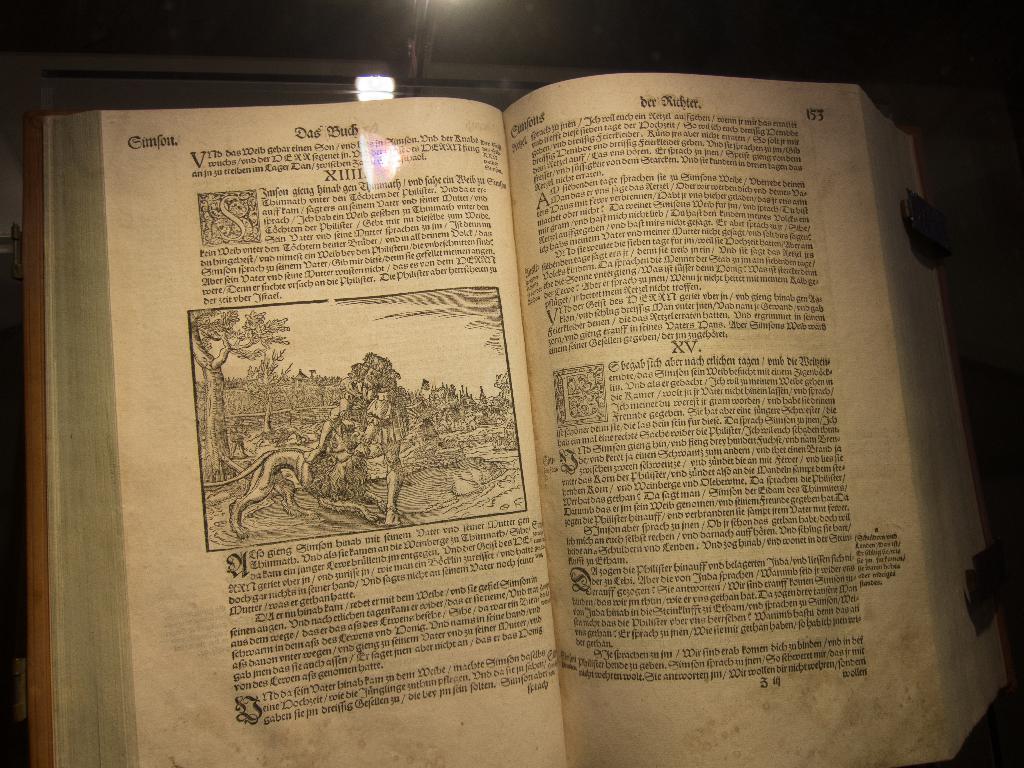How would you summarize this image in a sentence or two? In this picture we can see a book, and we can find some text in the book. 